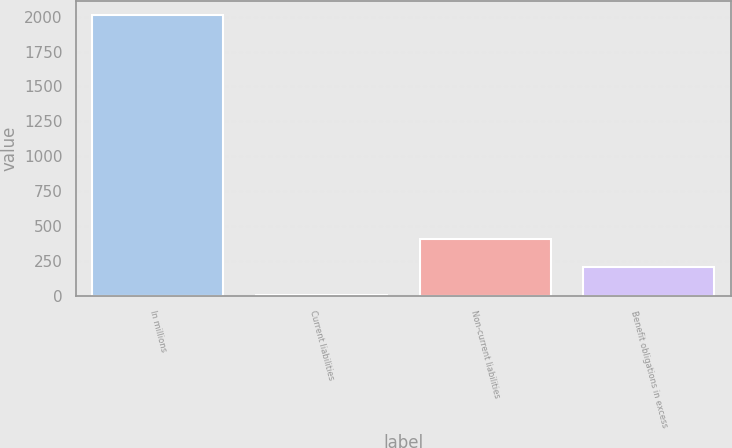Convert chart to OTSL. <chart><loc_0><loc_0><loc_500><loc_500><bar_chart><fcel>In millions<fcel>Current liabilities<fcel>Non-current liabilities<fcel>Benefit obligations in excess<nl><fcel>2014<fcel>4.7<fcel>406.56<fcel>205.63<nl></chart> 